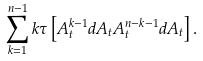Convert formula to latex. <formula><loc_0><loc_0><loc_500><loc_500>\sum _ { k = 1 } ^ { n - 1 } k \tau \left [ A _ { t } ^ { k - 1 } d A _ { t } A _ { t } ^ { n - k - 1 } d A _ { t } \right ] .</formula> 